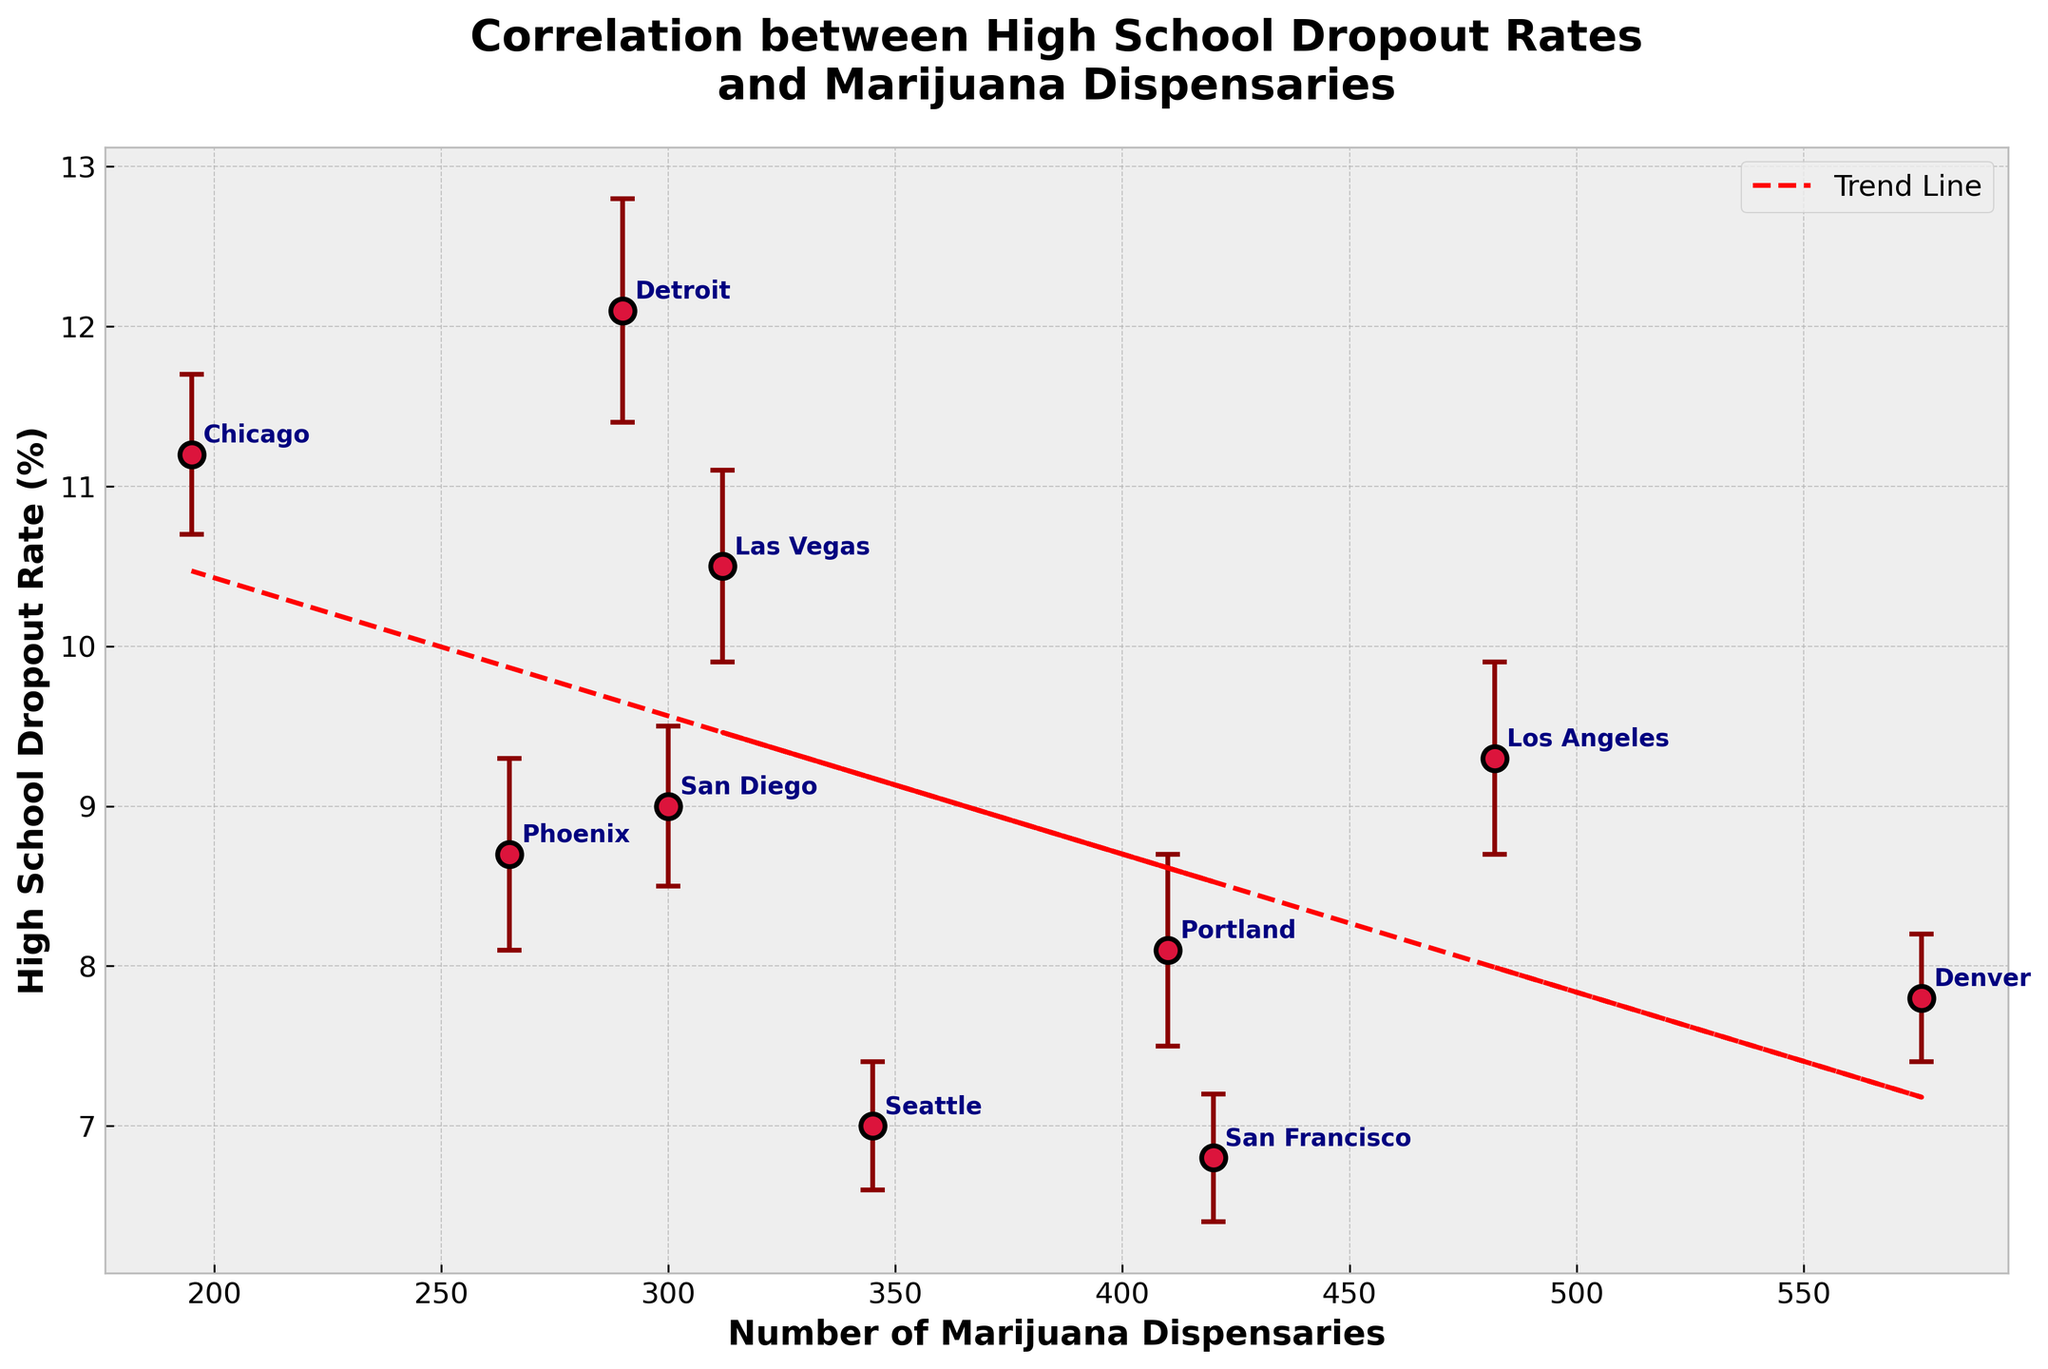What is the title of the figure? The title is displayed at the top of the plot. By reading it, we can determine that the title is "Correlation between High School Dropout Rates and Marijuana Dispensaries."
Answer: Correlation between High School Dropout Rates and Marijuana Dispensaries What does the x-axis represent? The x-axis is labeled at the bottom of the plot. From the label, we can see that it represents the "Number of Marijuana Dispensaries."
Answer: Number of Marijuana Dispensaries Which region has the highest high school dropout rate? By looking at the vertical positions of the points on the plot, we can identify the highest dropout rate value. The label next to this point indicates that Detroit has the highest dropout rate.
Answer: Detroit What is the high school dropout rate in San Francisco and its confidence interval? By locating the point labeled "San Francisco" and reading its y-value position, we can see the dropout rate is 6.8%. The confidence interval displayed next to the region in the dataset is 6.4-7.2%.
Answer: 6.8%, 6.4-7.2% Which region has the fewest marijuana dispensaries? By looking at the horizontal positions of the points on the plot, we can identify the lowest number of dispensaries. The label next to this point indicates that Chicago has the fewest dispensaries.
Answer: Chicago Is there a general trend observed between the number of marijuana dispensaries and high school dropout rates? The trend line added to the plot shows a pattern in the data. By inspecting the line, we can see if it slopes upwards or downwards. In this case, it slopes upward, indicating a positive correlation.
Answer: Positive correlation How does the high school dropout rate in Las Vegas compare to that in Denver? By comparing the vertical positions of the points labeled "Las Vegas" and "Denver," we can see that Las Vegas has a higher dropout rate than Denver. Las Vegas is at 10.5%, while Denver is at 7.8%.
Answer: Las Vegas is higher What is the trend line equation and what does it indicate? The trend line equation is typically displayed on the plot or can be inferred from the trend line itself. It shows the general relationship between the number of dispensaries and dropout rates. In this case, the equation is a simple linear regression model.
Answer: It indicates a positive correlation Which regions have high school dropout rates above 10%? By identifying points above the 10% mark on the y-axis, we can determine that Las Vegas (10.5%), Detroit (12.1%), and Chicago (11.2%) all have dropout rates above 10%.
Answer: Las Vegas, Detroit, Chicago What can be inferred from the confidence intervals regarding data reliability? Observing the error bars (representing confidence intervals) shows how much uncertainty is associated with each dropout rate. Larger intervals indicate more variability or less reliability, while smaller intervals show more precise measurements.
Answer: Variability or precision in measurements 